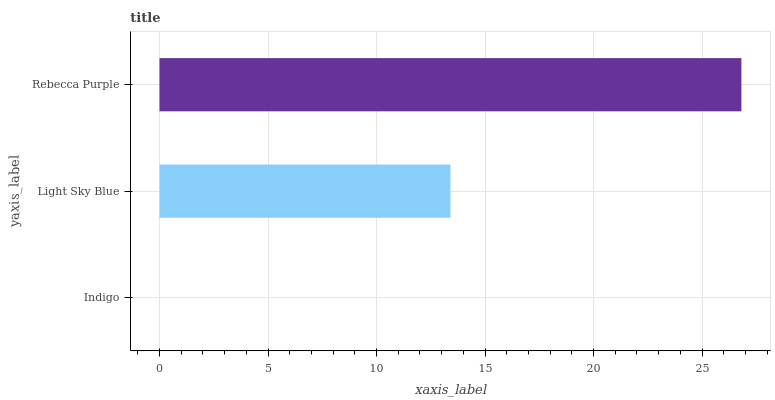Is Indigo the minimum?
Answer yes or no. Yes. Is Rebecca Purple the maximum?
Answer yes or no. Yes. Is Light Sky Blue the minimum?
Answer yes or no. No. Is Light Sky Blue the maximum?
Answer yes or no. No. Is Light Sky Blue greater than Indigo?
Answer yes or no. Yes. Is Indigo less than Light Sky Blue?
Answer yes or no. Yes. Is Indigo greater than Light Sky Blue?
Answer yes or no. No. Is Light Sky Blue less than Indigo?
Answer yes or no. No. Is Light Sky Blue the high median?
Answer yes or no. Yes. Is Light Sky Blue the low median?
Answer yes or no. Yes. Is Rebecca Purple the high median?
Answer yes or no. No. Is Indigo the low median?
Answer yes or no. No. 